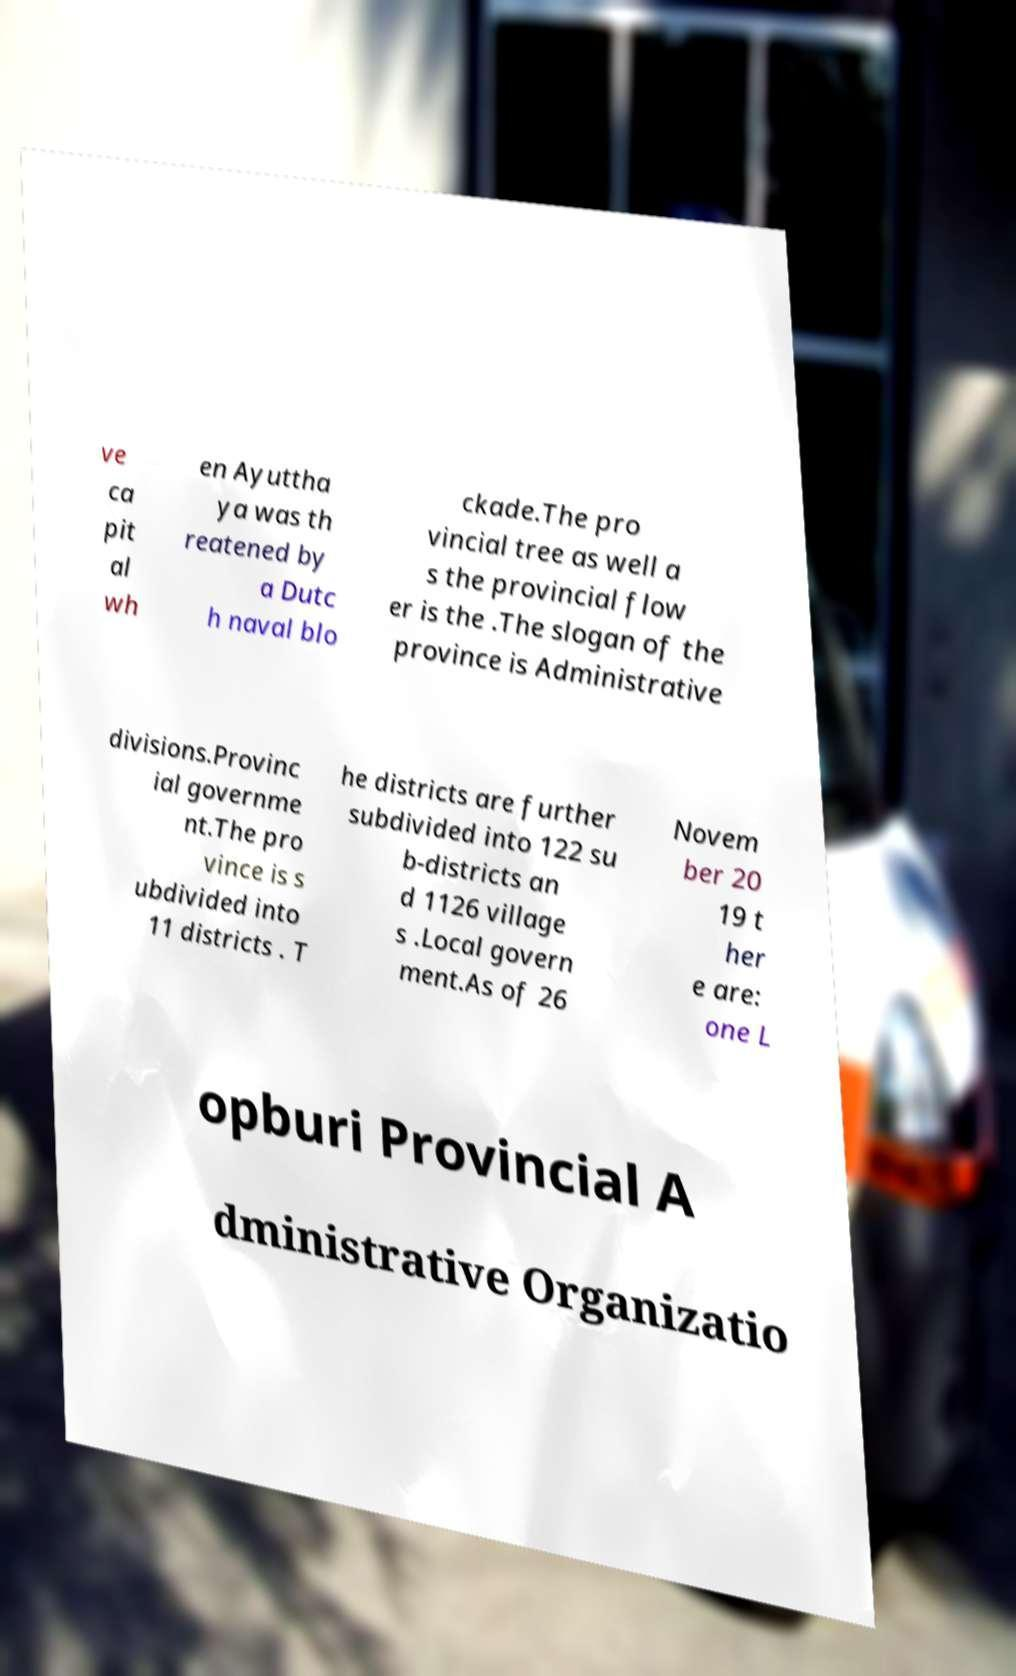What messages or text are displayed in this image? I need them in a readable, typed format. ve ca pit al wh en Ayuttha ya was th reatened by a Dutc h naval blo ckade.The pro vincial tree as well a s the provincial flow er is the .The slogan of the province is Administrative divisions.Provinc ial governme nt.The pro vince is s ubdivided into 11 districts . T he districts are further subdivided into 122 su b-districts an d 1126 village s .Local govern ment.As of 26 Novem ber 20 19 t her e are: one L opburi Provincial A dministrative Organizatio 